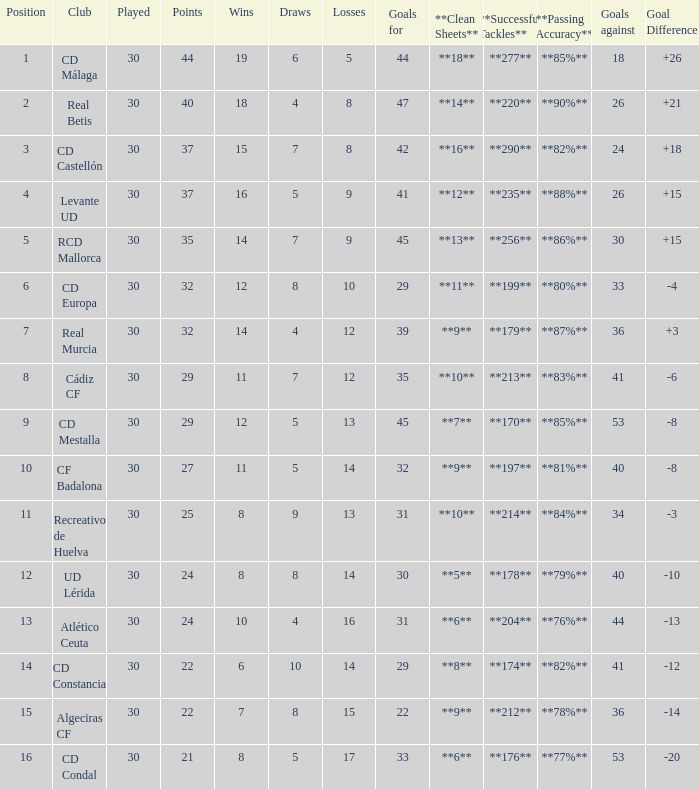What is the wins number when the points were smaller than 27, and goals against was 41? 6.0. 